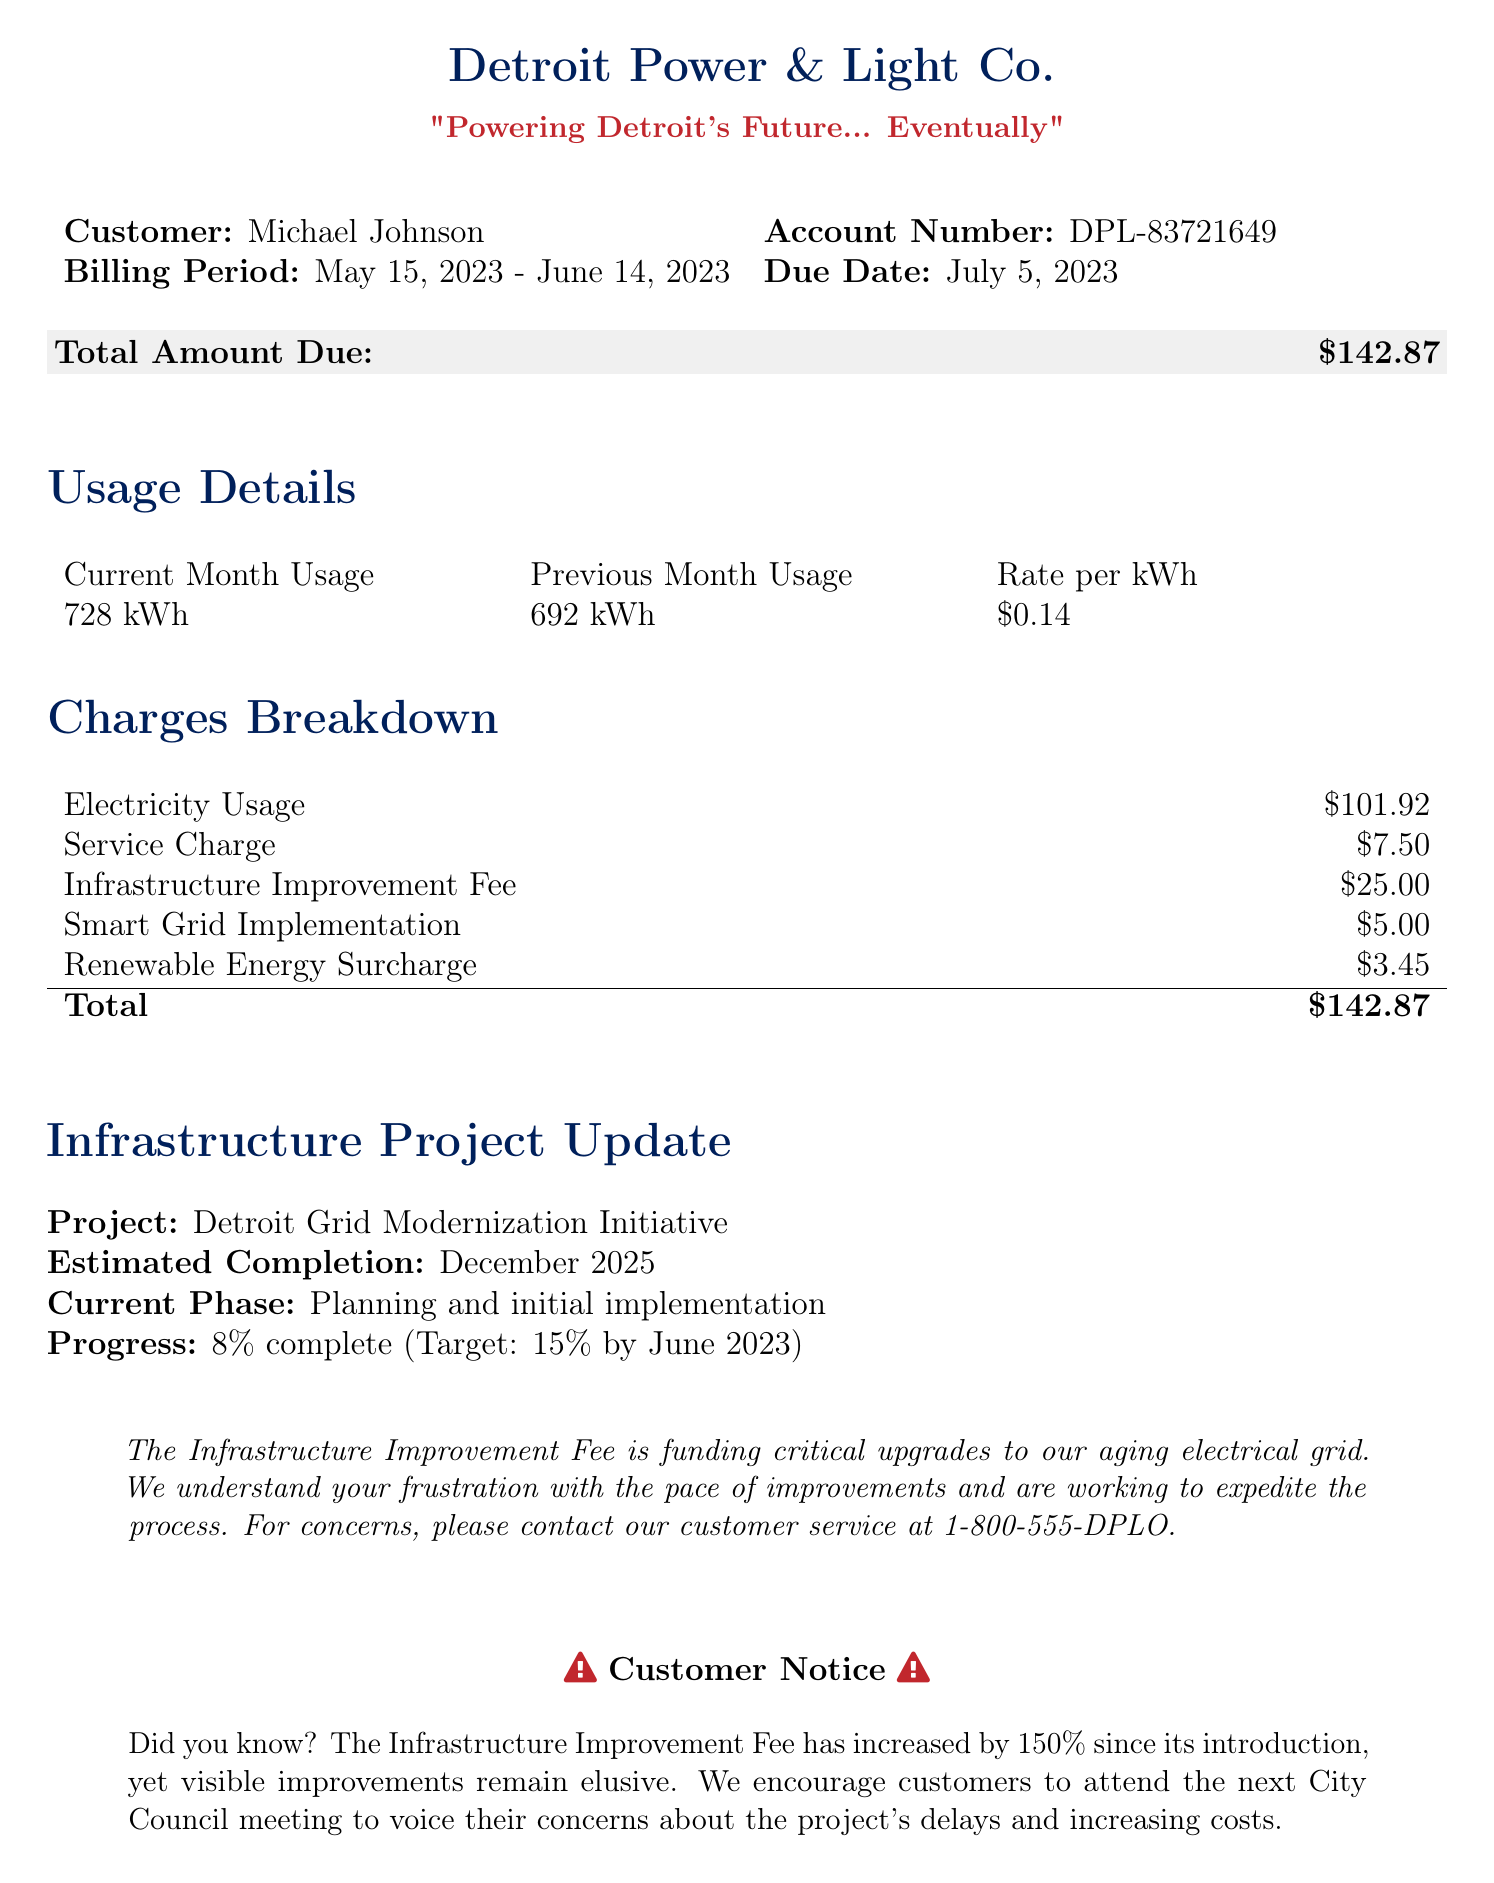What is the total amount due? The total amount due is clearly stated in the bill under the "Total Amount Due" section.
Answer: $142.87 What is the customer's name? The customer's name is provided at the beginning of the document.
Answer: Michael Johnson What is the billing period? The billing period is specified in the details section.
Answer: May 15, 2023 - June 14, 2023 What is the estimated completion date for the infrastructure project? The estimated completion date is mentioned under the "Infrastructure Project Update" section.
Answer: December 2025 What is the Infrastructure Improvement Fee amount? This fee amount is included in the "Charges Breakdown" section.
Answer: $25.00 What percentage complete is the Detroit Grid Modernization Initiative? The progress completion percentage is provided in the document.
Answer: 8% How much has the Infrastructure Improvement Fee increased since its introduction? The increase of this fee is stated in the customer notice.
Answer: 150% What is the current phase of the Detroit Grid Modernization Initiative? The current phase is outlined in the project update section.
Answer: Planning and initial implementation How much is the Service Charge? The Service Charge can be found in the "Charges Breakdown" table.
Answer: $7.50 